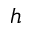<formula> <loc_0><loc_0><loc_500><loc_500>h</formula> 